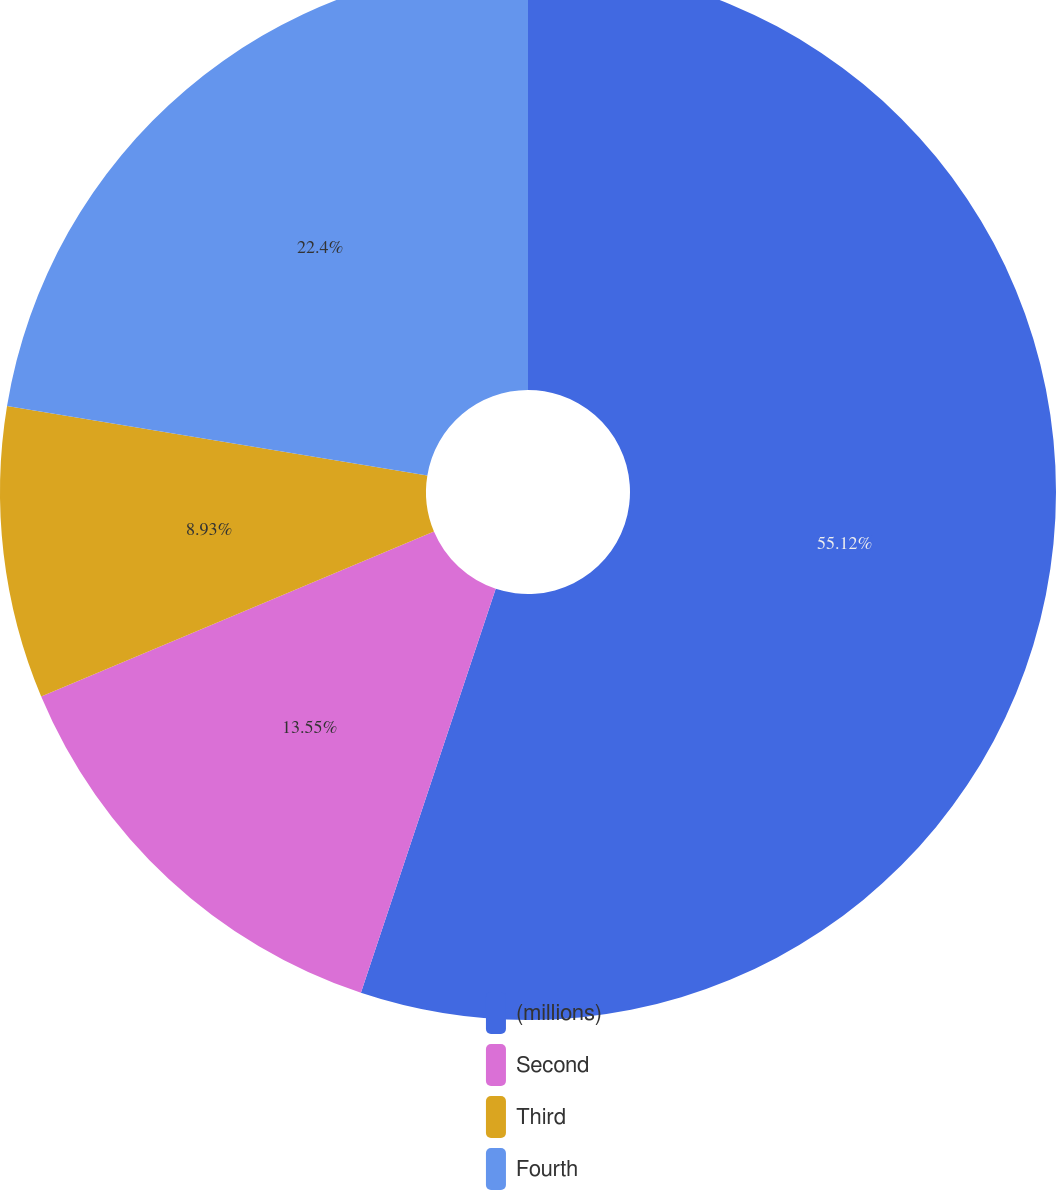<chart> <loc_0><loc_0><loc_500><loc_500><pie_chart><fcel>(millions)<fcel>Second<fcel>Third<fcel>Fourth<nl><fcel>55.13%<fcel>13.55%<fcel>8.93%<fcel>22.4%<nl></chart> 